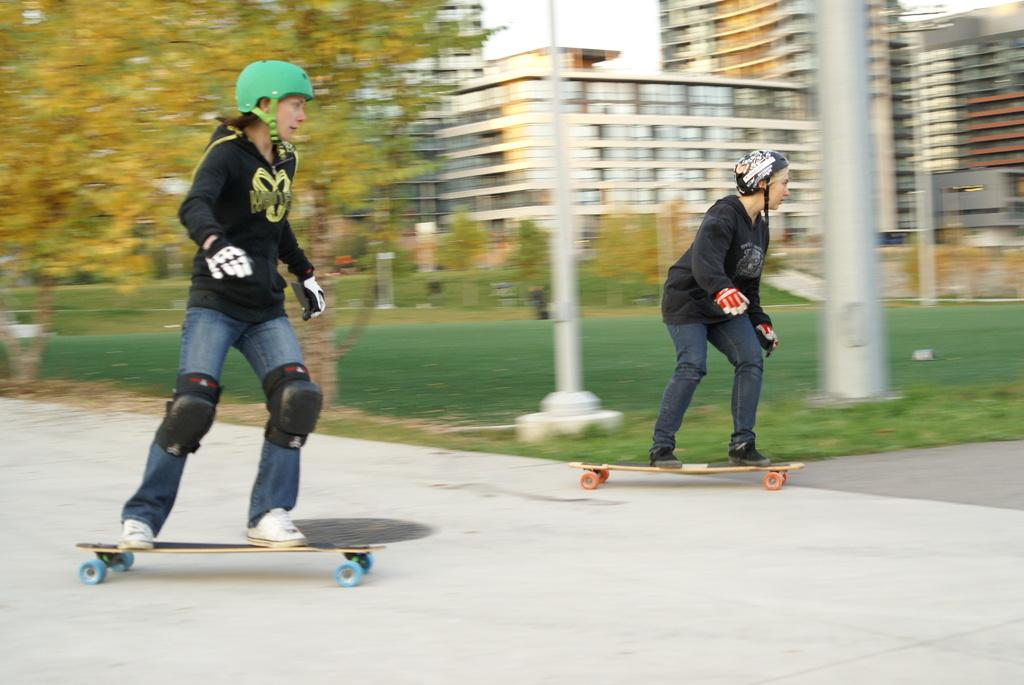How many people are in the image? There are two persons in the image. What are the persons doing in the image? The persons are skating on the road. What can be seen in the background of the image? There are trees, poles, buildings, and the sky visible in the background of the image. Can you tell me how many bees are buzzing around the cheese in the image? There is no cheese or bees present in the image. What type of thrill can be experienced by the persons in the image? The provided facts do not mention any specific thrill experienced by the persons in the image. 